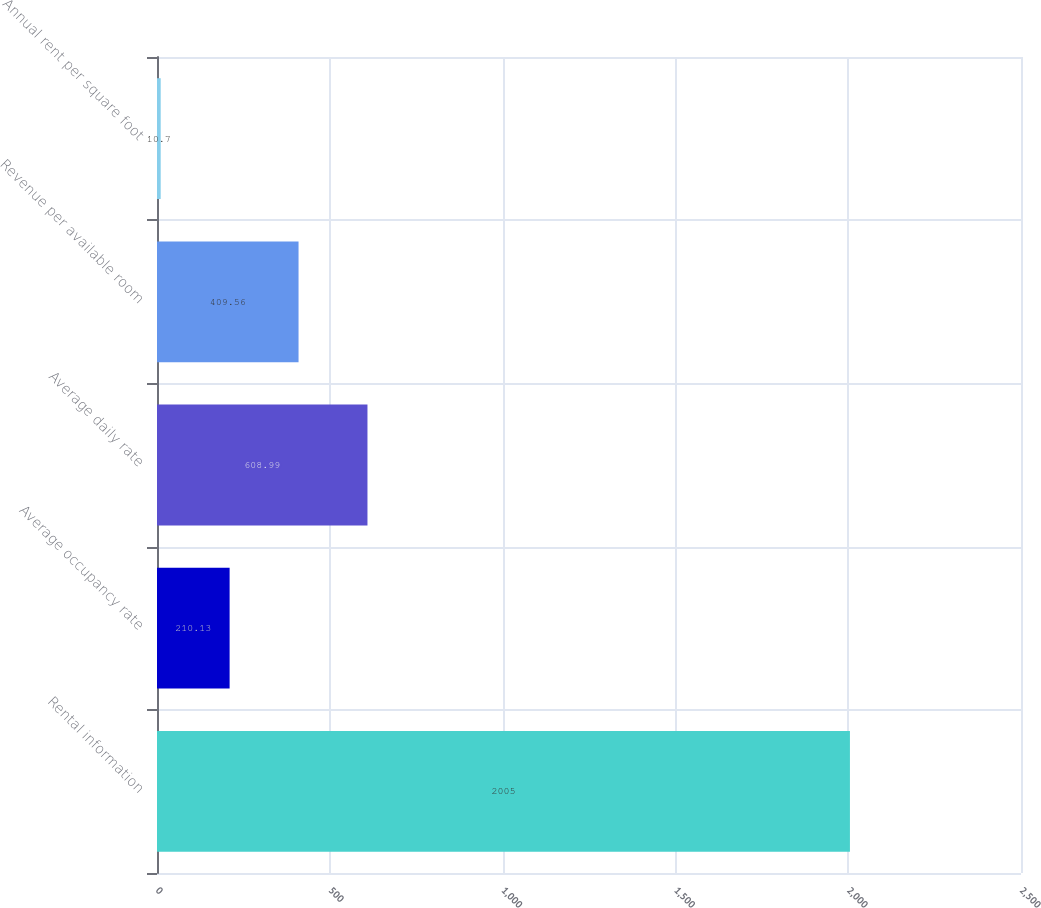Convert chart to OTSL. <chart><loc_0><loc_0><loc_500><loc_500><bar_chart><fcel>Rental information<fcel>Average occupancy rate<fcel>Average daily rate<fcel>Revenue per available room<fcel>Annual rent per square foot<nl><fcel>2005<fcel>210.13<fcel>608.99<fcel>409.56<fcel>10.7<nl></chart> 